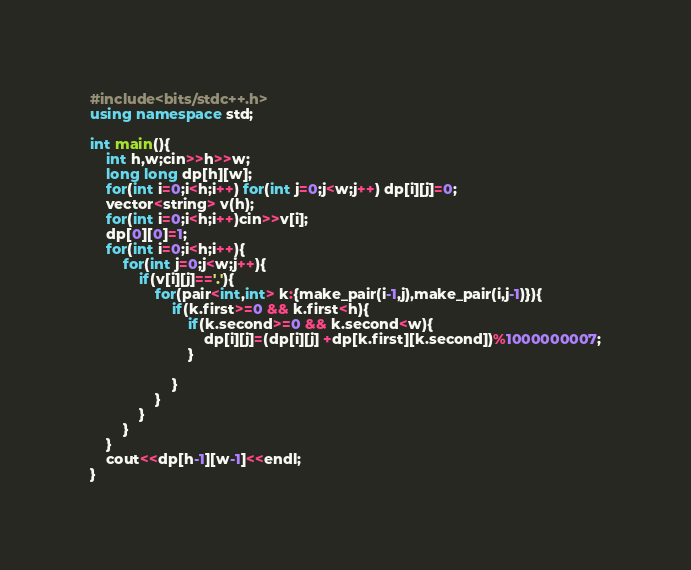<code> <loc_0><loc_0><loc_500><loc_500><_C++_>#include<bits/stdc++.h>
using namespace std;

int main(){
	int h,w;cin>>h>>w;
	long long dp[h][w];
	for(int i=0;i<h;i++) for(int j=0;j<w;j++) dp[i][j]=0;
	vector<string> v(h);
	for(int i=0;i<h;i++)cin>>v[i];
	dp[0][0]=1;
	for(int i=0;i<h;i++){
		for(int j=0;j<w;j++){
			if(v[i][j]=='.'){
				for(pair<int,int> k:{make_pair(i-1,j),make_pair(i,j-1)}){
					if(k.first>=0 && k.first<h){
						if(k.second>=0 && k.second<w){
							dp[i][j]=(dp[i][j] +dp[k.first][k.second])%1000000007;
						}

					}
				}
			}
		}
	}
	cout<<dp[h-1][w-1]<<endl;
}</code> 